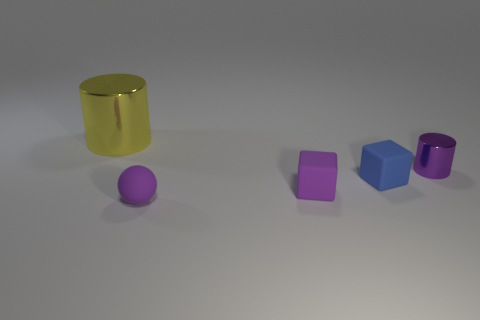There is a matte thing that is the same color as the tiny ball; what shape is it?
Offer a terse response. Cube. What material is the object to the left of the purple sphere?
Your response must be concise. Metal. Does the yellow metal cylinder have the same size as the purple rubber block?
Offer a very short reply. No. Are there more metal objects that are behind the yellow metal thing than metal objects?
Provide a short and direct response. No. There is a blue object that is the same material as the tiny sphere; what size is it?
Your answer should be very brief. Small. There is a purple cylinder; are there any small metallic cylinders on the left side of it?
Offer a terse response. No. Do the large yellow shiny object and the blue matte thing have the same shape?
Keep it short and to the point. No. There is a shiny thing behind the metal object to the right of the shiny cylinder that is behind the tiny purple shiny object; what is its size?
Offer a very short reply. Large. What is the big yellow object made of?
Provide a short and direct response. Metal. There is a ball that is the same color as the tiny cylinder; what size is it?
Keep it short and to the point. Small. 